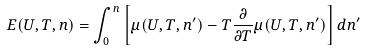<formula> <loc_0><loc_0><loc_500><loc_500>E ( U , T , n ) = \int _ { 0 } ^ { n } \left [ \mu ( U , T , n ^ { \prime } ) - T \frac { \partial } { \partial T } \mu ( U , T , n ^ { \prime } ) \right ] d n ^ { \prime }</formula> 